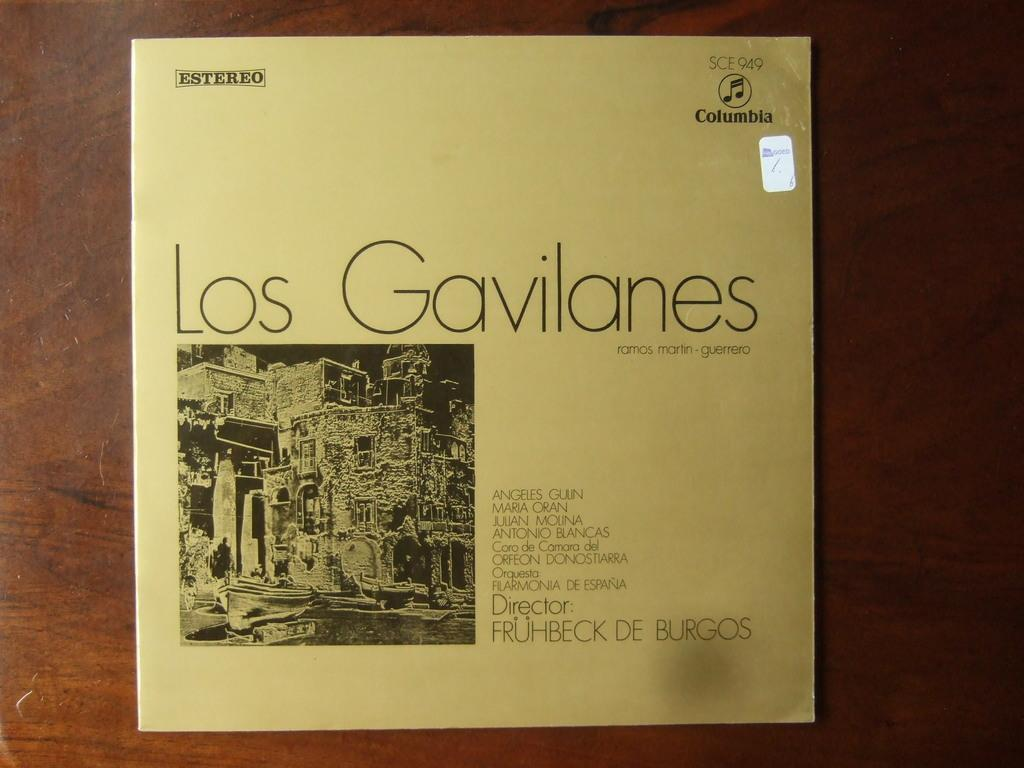<image>
Present a compact description of the photo's key features. The record cover has the word Estereo at the top. 